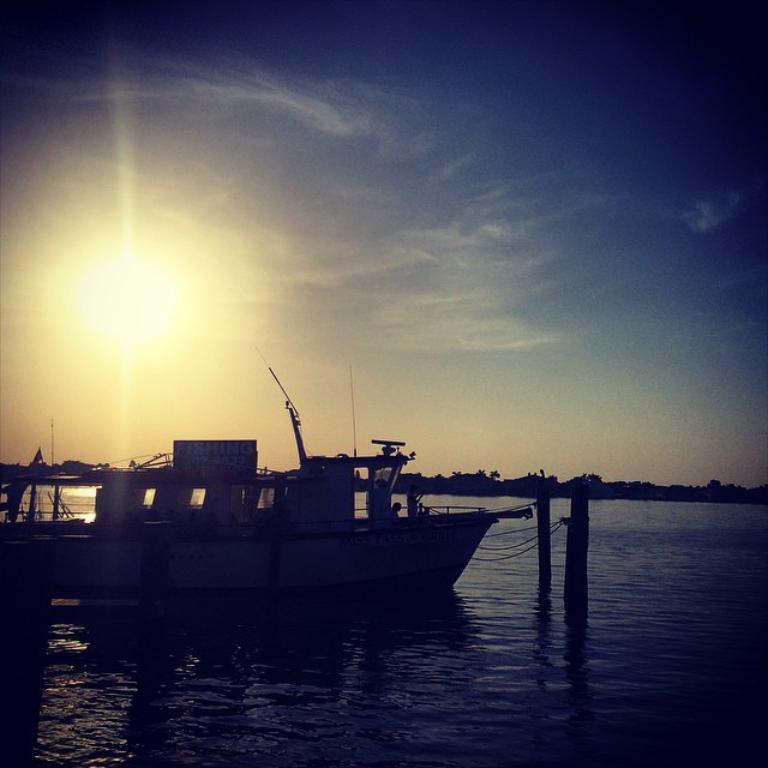Describe this image in one or two sentences. This picture is taken from the outside of the city. In this image, on the left side, we can see a boat which is drowning on the water, in the boat, we can see a person. In the middle of the image, we can see two poles and ropes. In the background, we can see some trees and black color. At the top, we can see a sky and a sun, at the bottom, we can see a water. 